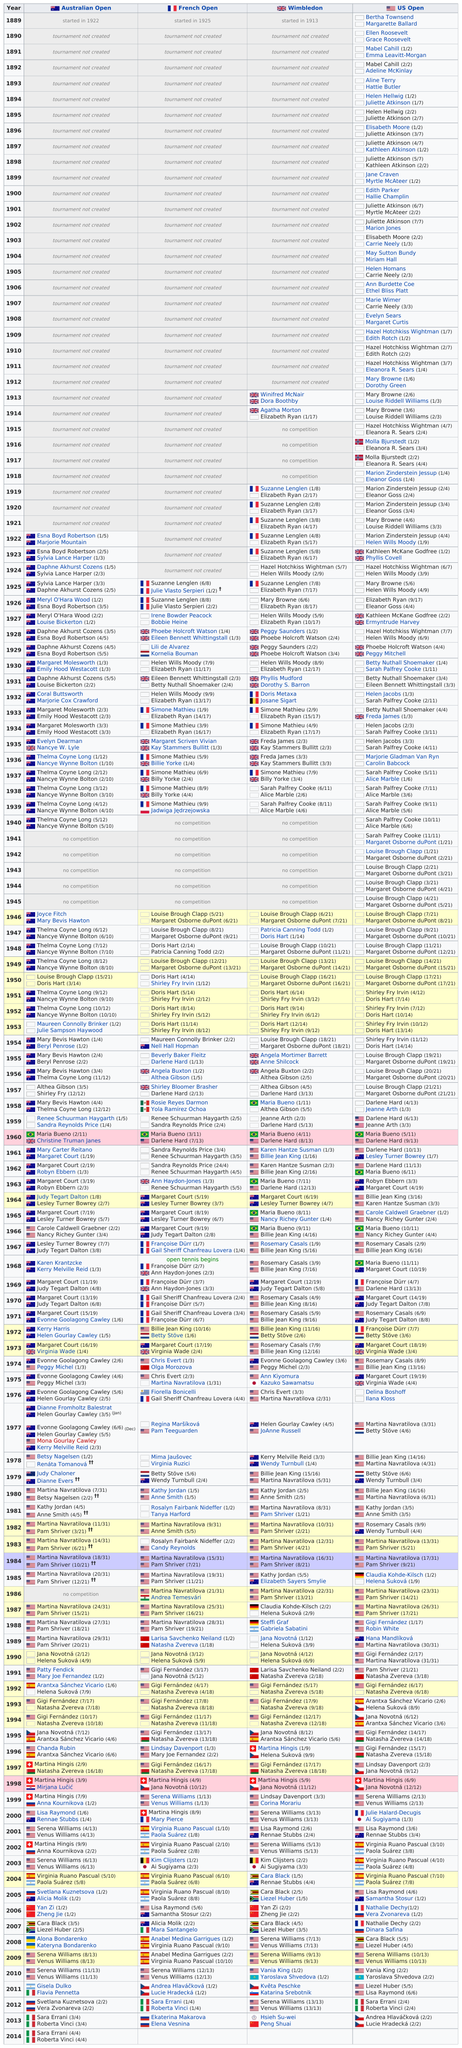Indicate a few pertinent items in this graphic. Serena Williams has won more championships than Lisa Raymond. The first year of the Australian Open was 1922. Lili de Alvarez was the only Spanish tennis player who won during 1929. A team consisting solely of Chinese players has won a championship twice. Doris Hart did not win the Australian Open in the years 1951, 1952, or 1953. 